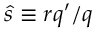<formula> <loc_0><loc_0><loc_500><loc_500>\hat { s } \equiv r q ^ { \prime } / q</formula> 